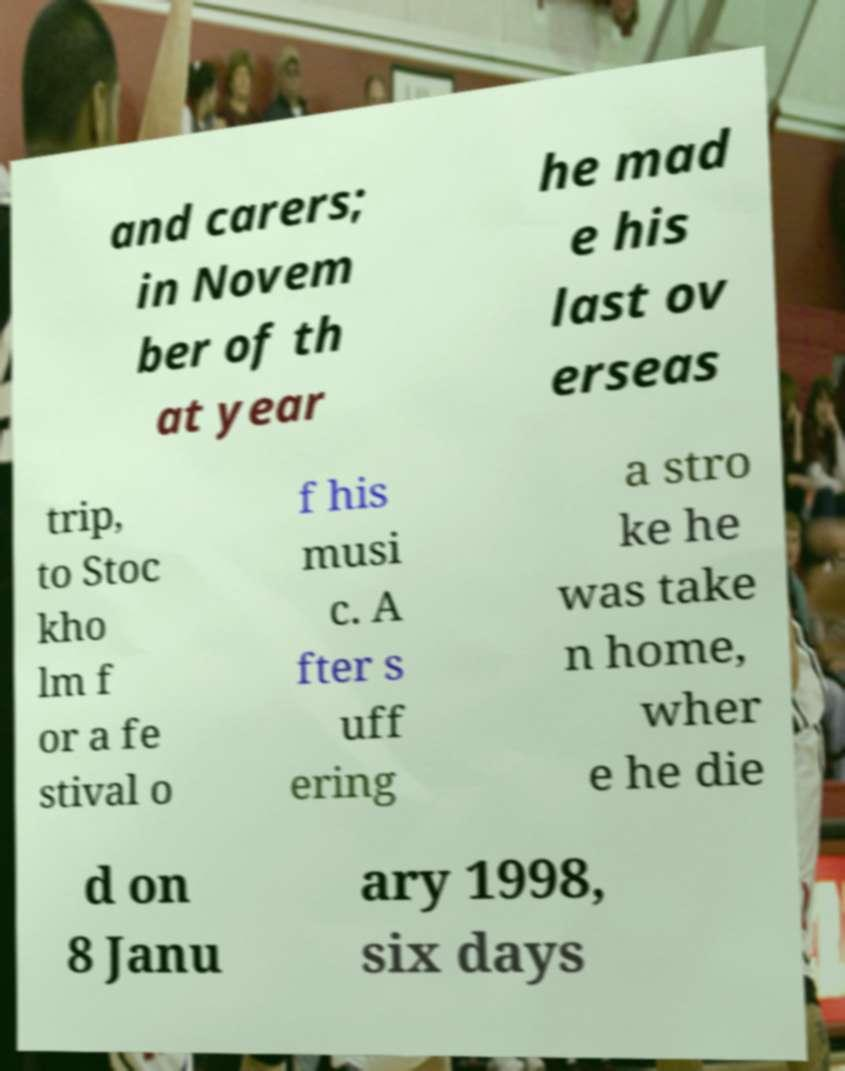Please read and relay the text visible in this image. What does it say? and carers; in Novem ber of th at year he mad e his last ov erseas trip, to Stoc kho lm f or a fe stival o f his musi c. A fter s uff ering a stro ke he was take n home, wher e he die d on 8 Janu ary 1998, six days 